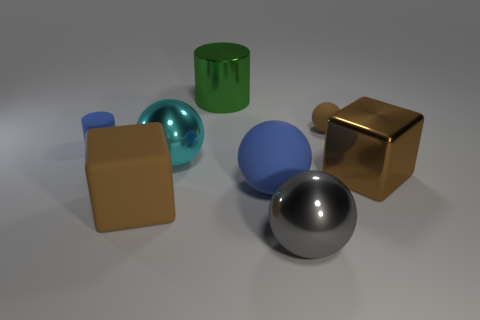Subtract all small brown balls. How many balls are left? 3 Subtract 2 spheres. How many spheres are left? 2 Add 2 matte objects. How many objects exist? 10 Subtract all blue spheres. How many spheres are left? 3 Subtract all red balls. Subtract all brown cubes. How many balls are left? 4 Add 2 gray objects. How many gray objects are left? 3 Add 5 big metal cylinders. How many big metal cylinders exist? 6 Subtract 0 brown cylinders. How many objects are left? 8 Subtract all cylinders. How many objects are left? 6 Subtract all gray shiny cubes. Subtract all large gray objects. How many objects are left? 7 